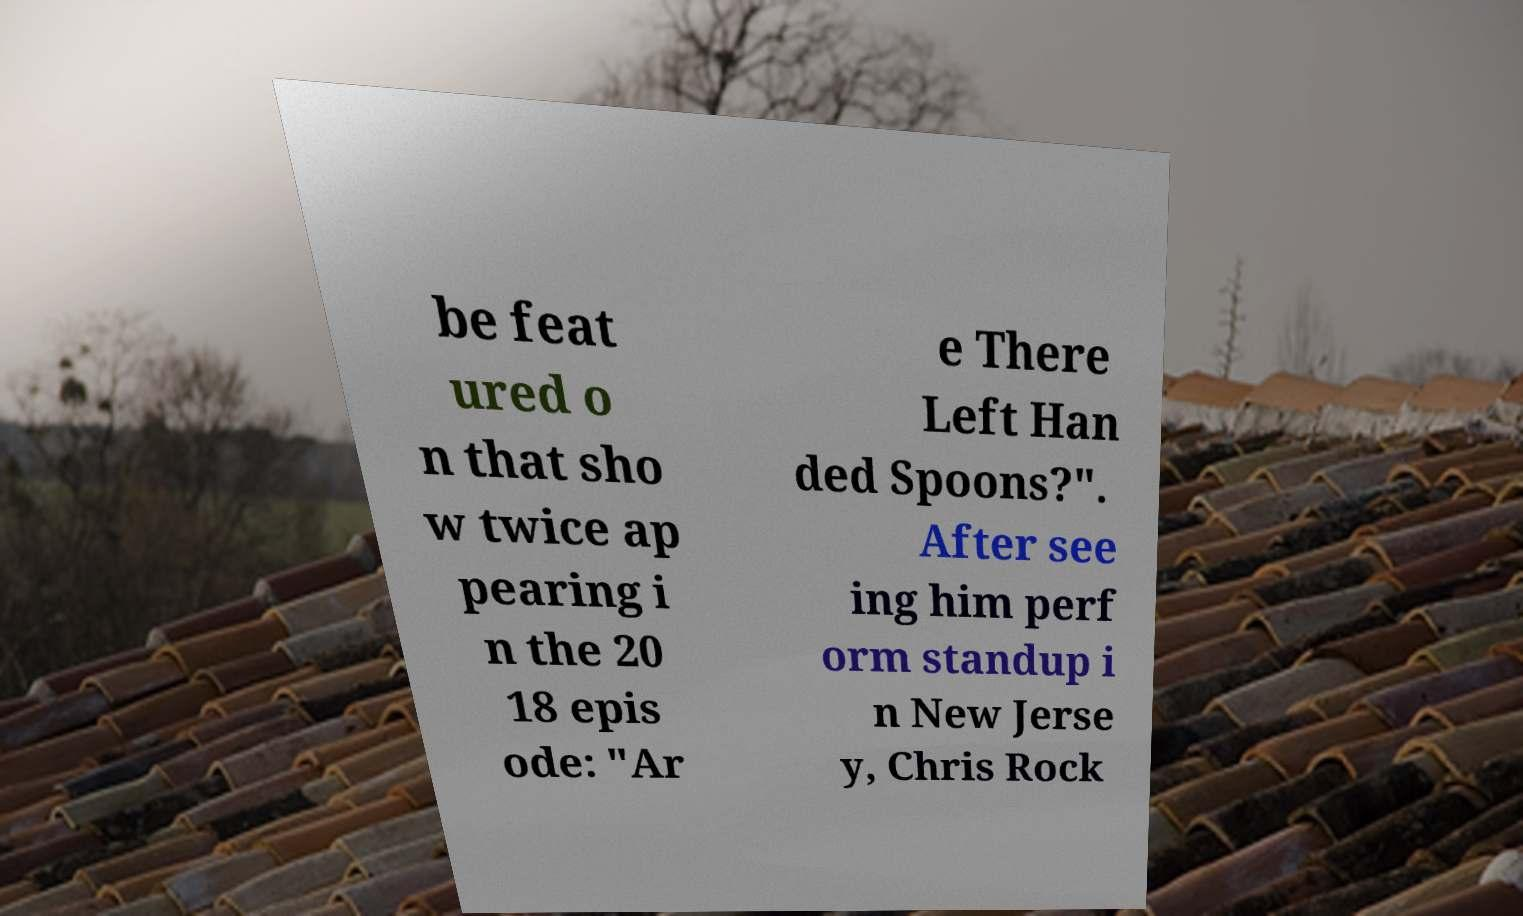For documentation purposes, I need the text within this image transcribed. Could you provide that? be feat ured o n that sho w twice ap pearing i n the 20 18 epis ode: "Ar e There Left Han ded Spoons?". After see ing him perf orm standup i n New Jerse y, Chris Rock 